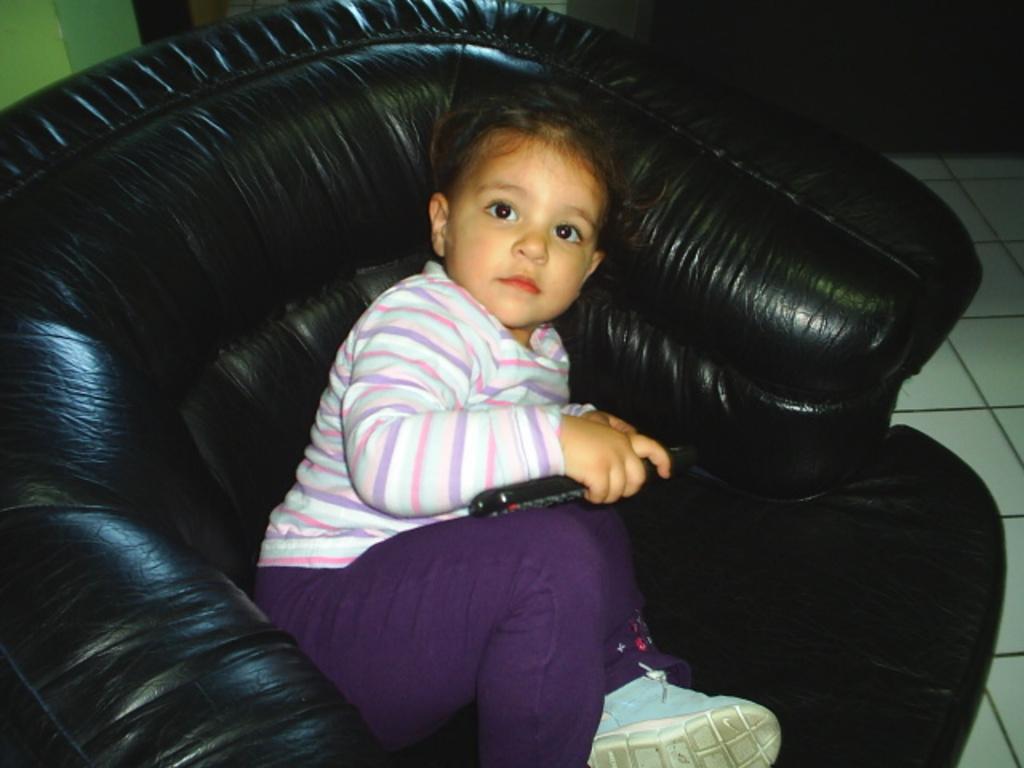Please provide a concise description of this image. In this picture we have a baby, she holds remote control and she wears shoes. She is sitting in sofa which is black in color and it seems like a house. 